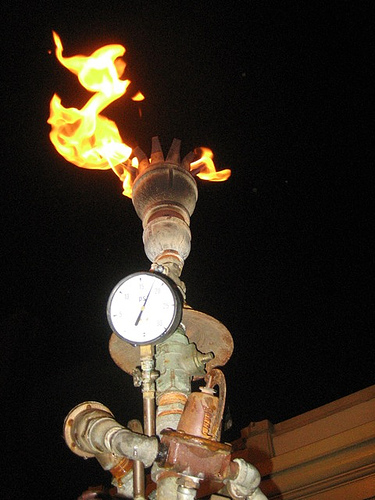<image>
Is there a fire on the torch? Yes. Looking at the image, I can see the fire is positioned on top of the torch, with the torch providing support. 